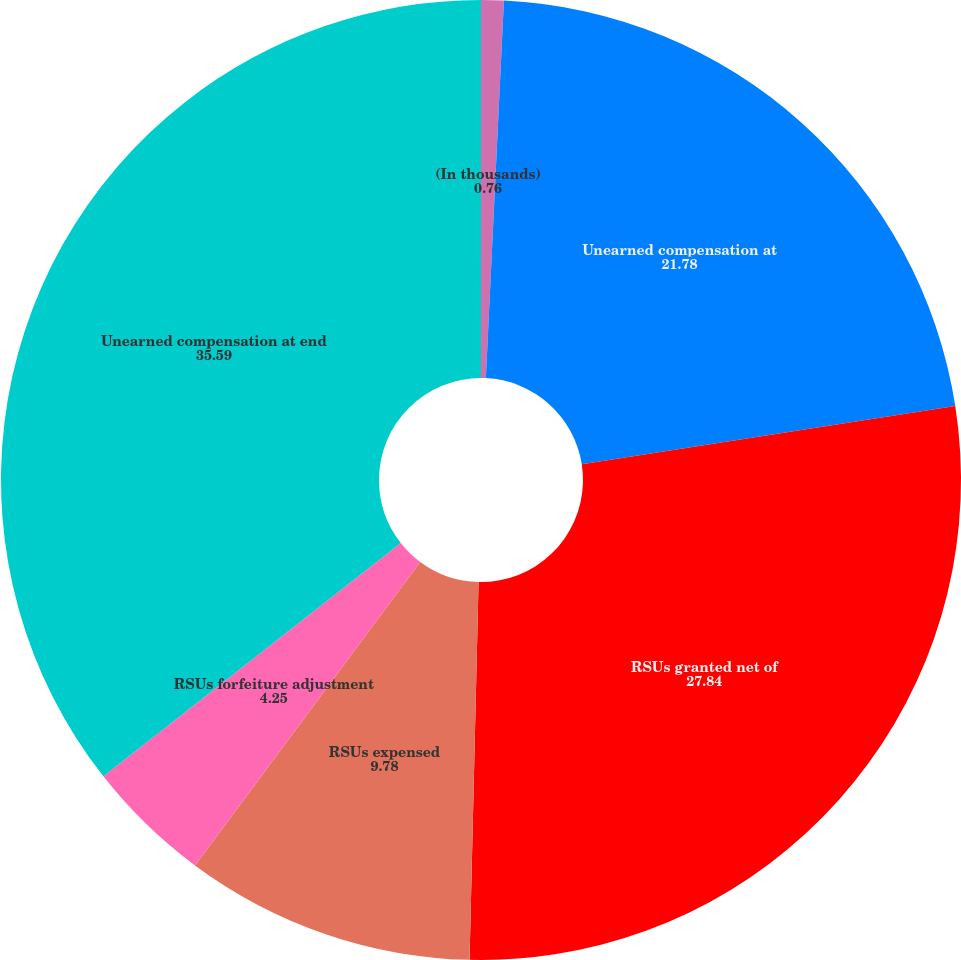Convert chart. <chart><loc_0><loc_0><loc_500><loc_500><pie_chart><fcel>(In thousands)<fcel>Unearned compensation at<fcel>RSUs granted net of<fcel>RSUs expensed<fcel>RSUs forfeiture adjustment<fcel>Unearned compensation at end<nl><fcel>0.76%<fcel>21.78%<fcel>27.84%<fcel>9.78%<fcel>4.25%<fcel>35.59%<nl></chart> 